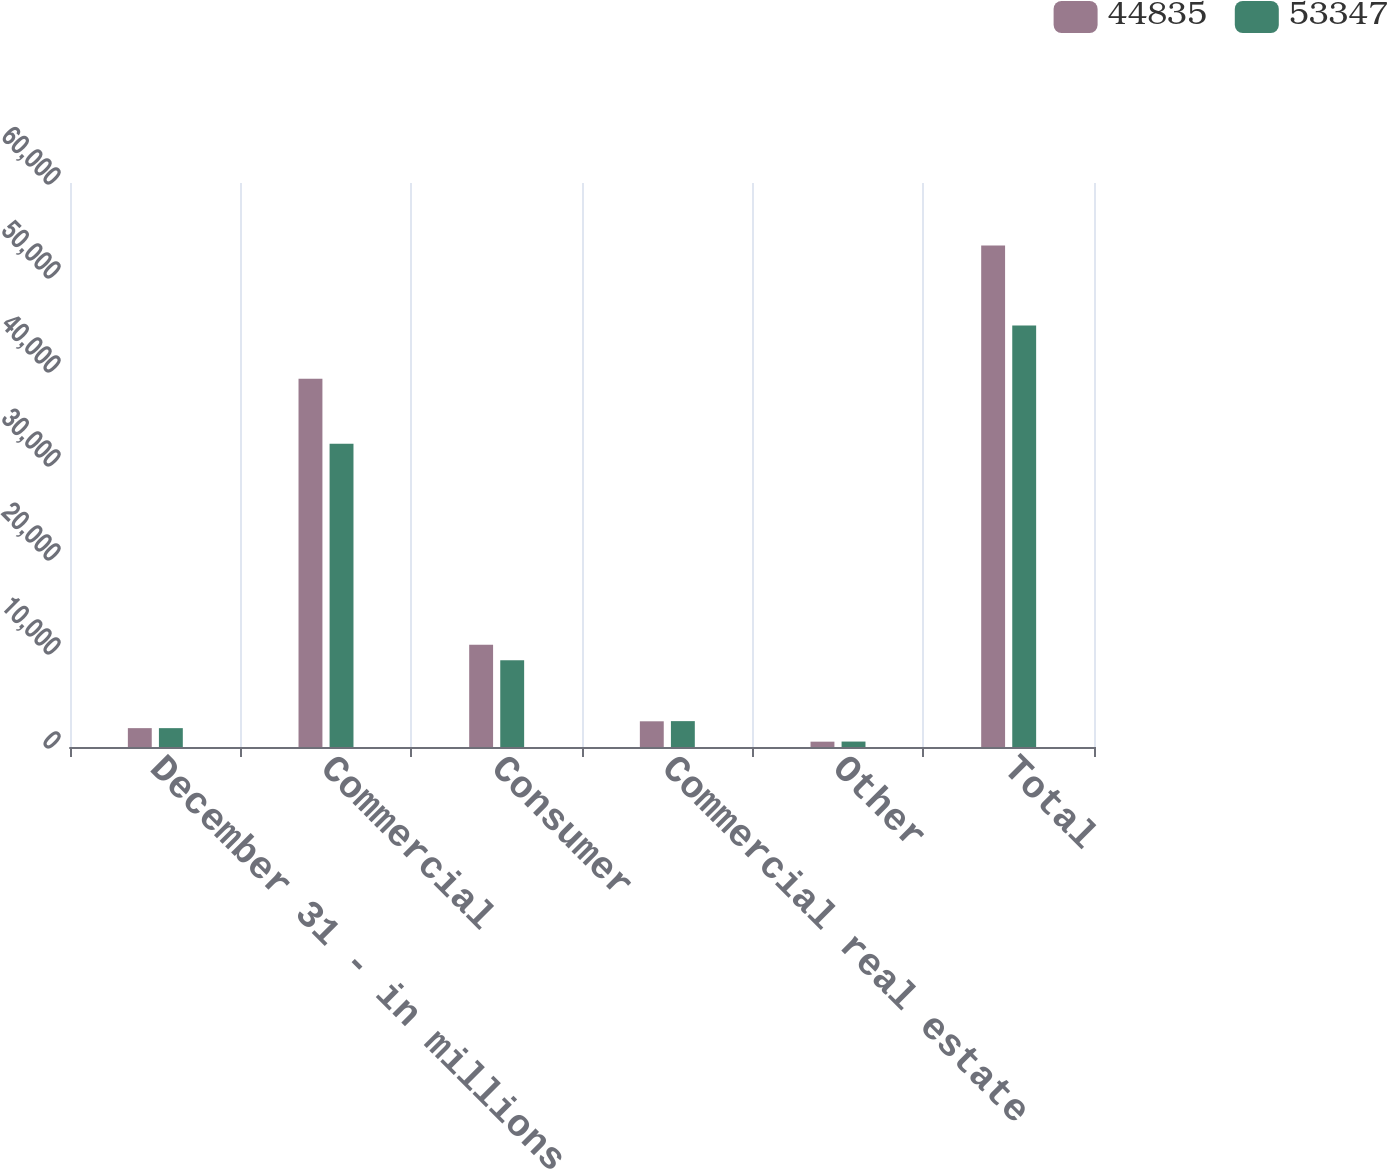<chart> <loc_0><loc_0><loc_500><loc_500><stacked_bar_chart><ecel><fcel>December 31 - in millions<fcel>Commercial<fcel>Consumer<fcel>Commercial real estate<fcel>Other<fcel>Total<nl><fcel>44835<fcel>2007<fcel>39171<fcel>10875<fcel>2734<fcel>567<fcel>53347<nl><fcel>53347<fcel>2006<fcel>32265<fcel>9239<fcel>2752<fcel>579<fcel>44835<nl></chart> 